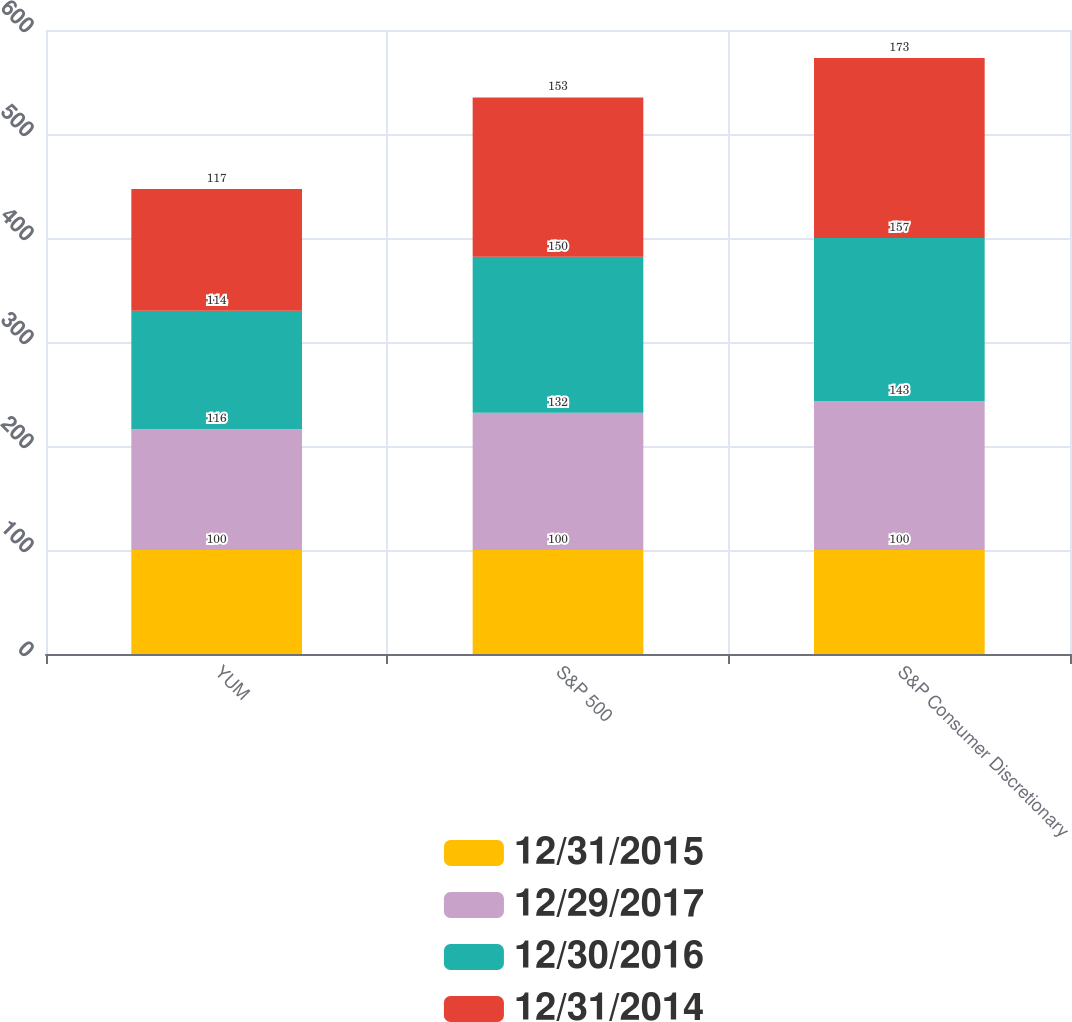<chart> <loc_0><loc_0><loc_500><loc_500><stacked_bar_chart><ecel><fcel>YUM<fcel>S&P 500<fcel>S&P Consumer Discretionary<nl><fcel>12/31/2015<fcel>100<fcel>100<fcel>100<nl><fcel>12/29/2017<fcel>116<fcel>132<fcel>143<nl><fcel>12/30/2016<fcel>114<fcel>150<fcel>157<nl><fcel>12/31/2014<fcel>117<fcel>153<fcel>173<nl></chart> 